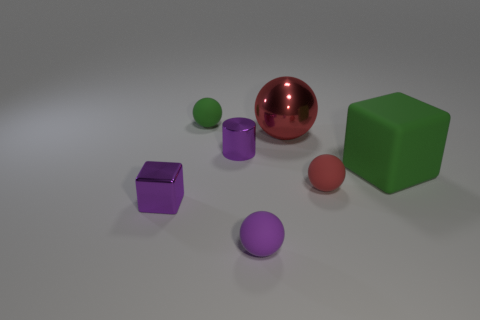Add 1 brown spheres. How many objects exist? 8 Subtract all blocks. How many objects are left? 5 Add 3 tiny red objects. How many tiny red objects exist? 4 Subtract 0 gray blocks. How many objects are left? 7 Subtract all small red metallic objects. Subtract all cylinders. How many objects are left? 6 Add 6 tiny red spheres. How many tiny red spheres are left? 7 